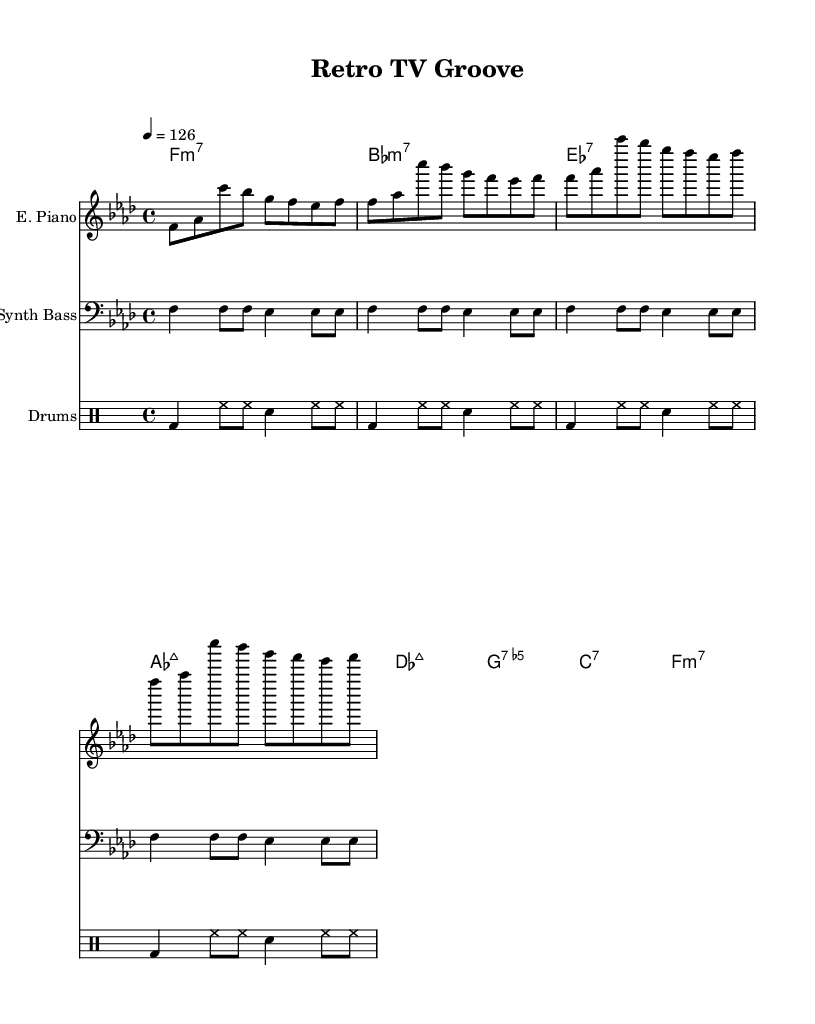What is the key signature of this music? The key signature has four flats, indicating F minor. The key signature is found at the beginning of the staff.
Answer: F minor What is the time signature of this piece? The time signature is located at the beginning of the score, which shows 4/4, meaning there are four beats per measure and the quarter note gets one beat.
Answer: 4/4 What is the tempo marking for this piece? The tempo marking is provided within the score indicating the speed of 126 beats per minute. This information is stated above the staff for reference.
Answer: 126 How many measures are in each section of the music? Each section contains four measures; this can be calculated by counting the vertical bar lines separating each measure in the staff.
Answer: 4 What type of instrument plays the electric piano? The instrument name "E. Piano" is notated above the staff and indicates that an electric piano is used for this part.
Answer: Electric Piano What is the chord name for the first measure? The chord name written above the first measure is F minor 7, which can be discerned from the chord names written in chord symbols.
Answer: F:m7 Which instrument plays the drum pattern? The instrument name "Drums" is listed above the drum staff indicating that this staff is meant for drums.
Answer: Drums 